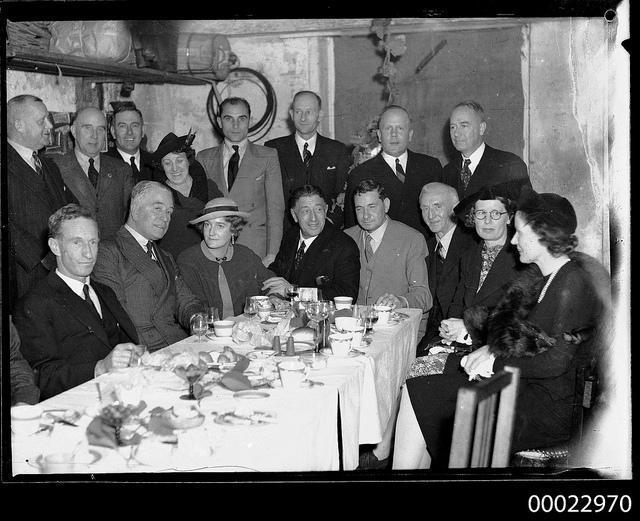How many people are there?
Give a very brief answer. 14. How many forks are on the table?
Give a very brief answer. 0. 